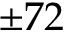<formula> <loc_0><loc_0><loc_500><loc_500>\pm 7 2</formula> 